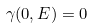<formula> <loc_0><loc_0><loc_500><loc_500>\gamma ( 0 , E ) = 0</formula> 